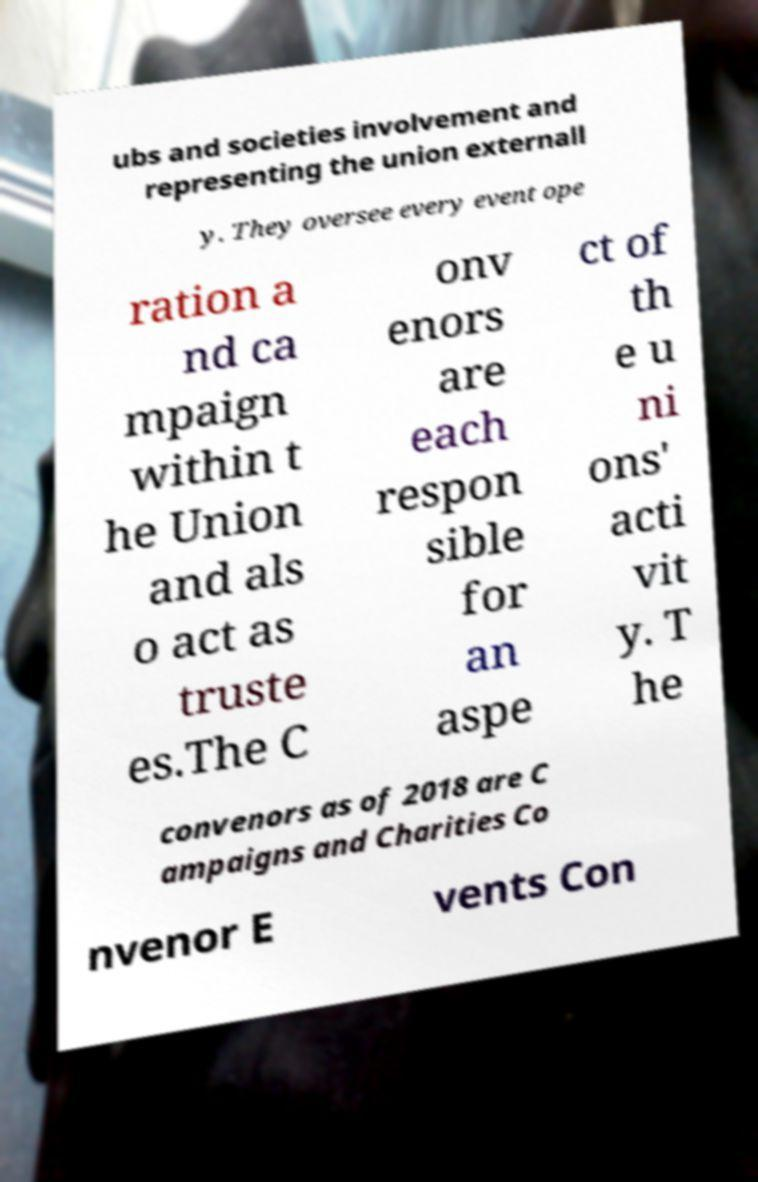Please identify and transcribe the text found in this image. ubs and societies involvement and representing the union externall y. They oversee every event ope ration a nd ca mpaign within t he Union and als o act as truste es.The C onv enors are each respon sible for an aspe ct of th e u ni ons' acti vit y. T he convenors as of 2018 are C ampaigns and Charities Co nvenor E vents Con 